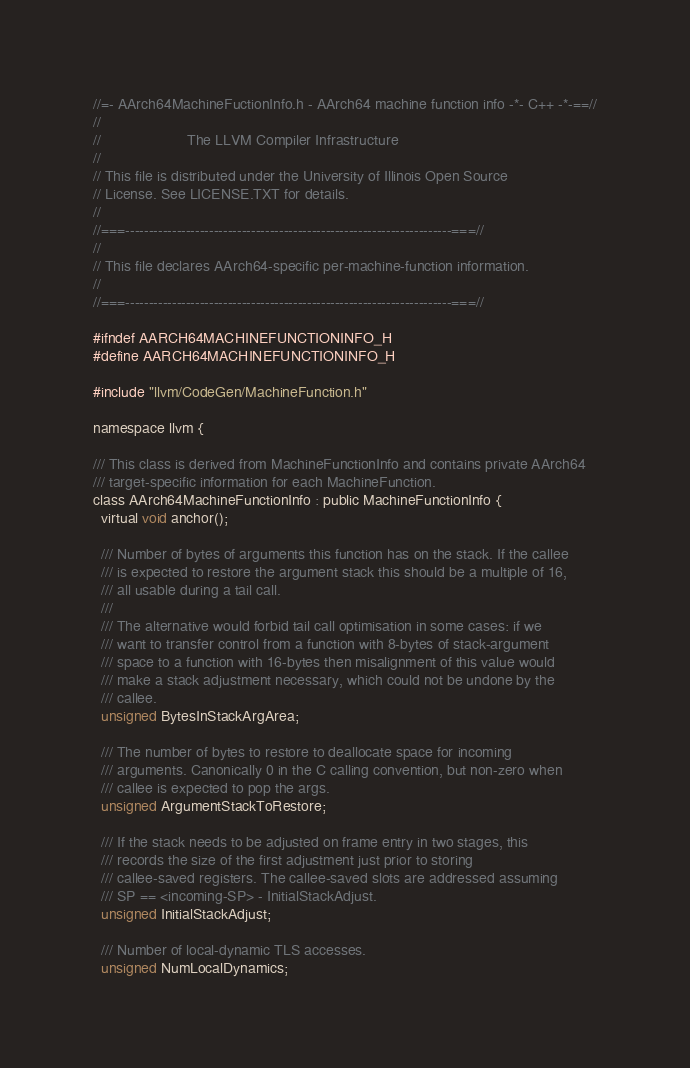<code> <loc_0><loc_0><loc_500><loc_500><_C_>//=- AArch64MachineFuctionInfo.h - AArch64 machine function info -*- C++ -*-==//
//
//                     The LLVM Compiler Infrastructure
//
// This file is distributed under the University of Illinois Open Source
// License. See LICENSE.TXT for details.
//
//===----------------------------------------------------------------------===//
//
// This file declares AArch64-specific per-machine-function information.
//
//===----------------------------------------------------------------------===//

#ifndef AARCH64MACHINEFUNCTIONINFO_H
#define AARCH64MACHINEFUNCTIONINFO_H

#include "llvm/CodeGen/MachineFunction.h"

namespace llvm {

/// This class is derived from MachineFunctionInfo and contains private AArch64
/// target-specific information for each MachineFunction.
class AArch64MachineFunctionInfo : public MachineFunctionInfo {
  virtual void anchor();

  /// Number of bytes of arguments this function has on the stack. If the callee
  /// is expected to restore the argument stack this should be a multiple of 16,
  /// all usable during a tail call.
  ///
  /// The alternative would forbid tail call optimisation in some cases: if we
  /// want to transfer control from a function with 8-bytes of stack-argument
  /// space to a function with 16-bytes then misalignment of this value would
  /// make a stack adjustment necessary, which could not be undone by the
  /// callee.
  unsigned BytesInStackArgArea;

  /// The number of bytes to restore to deallocate space for incoming
  /// arguments. Canonically 0 in the C calling convention, but non-zero when
  /// callee is expected to pop the args.
  unsigned ArgumentStackToRestore;

  /// If the stack needs to be adjusted on frame entry in two stages, this
  /// records the size of the first adjustment just prior to storing
  /// callee-saved registers. The callee-saved slots are addressed assuming
  /// SP == <incoming-SP> - InitialStackAdjust.
  unsigned InitialStackAdjust;

  /// Number of local-dynamic TLS accesses.
  unsigned NumLocalDynamics;
</code> 